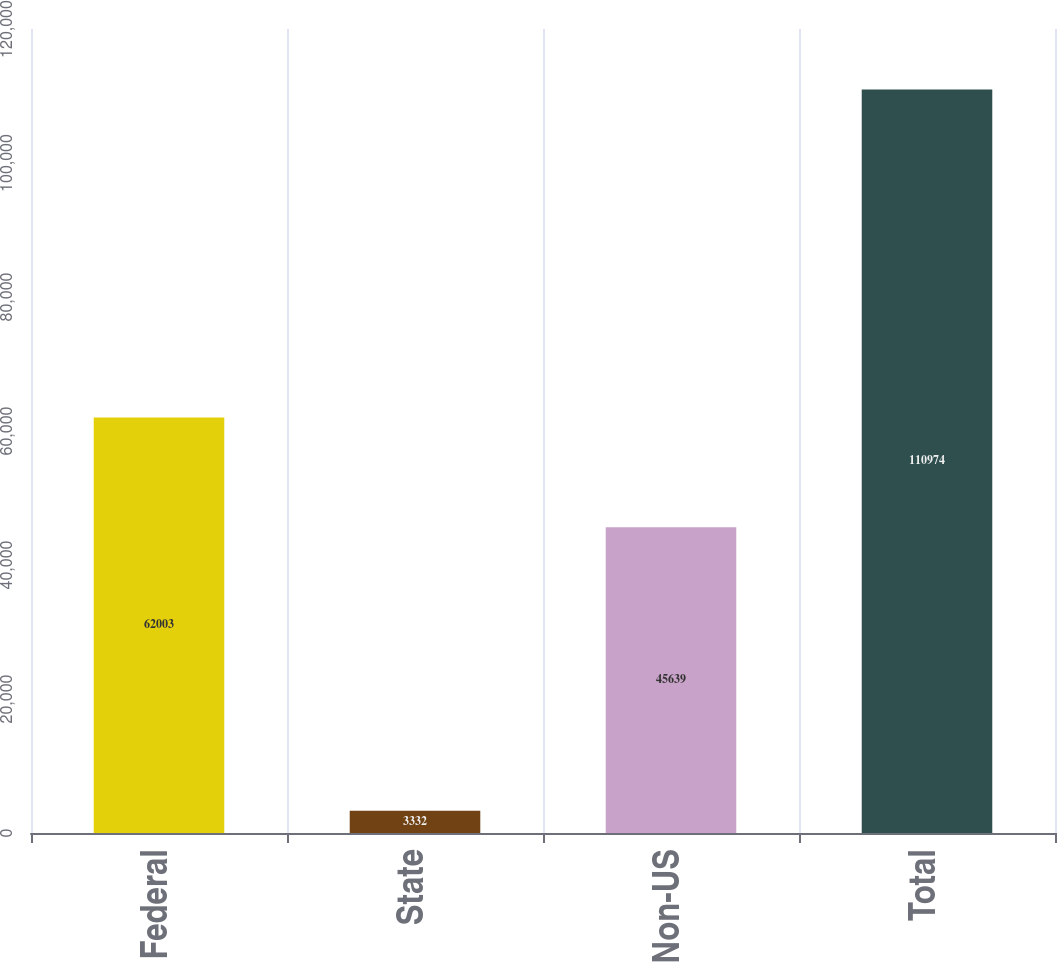Convert chart. <chart><loc_0><loc_0><loc_500><loc_500><bar_chart><fcel>Federal<fcel>State<fcel>Non-US<fcel>Total<nl><fcel>62003<fcel>3332<fcel>45639<fcel>110974<nl></chart> 